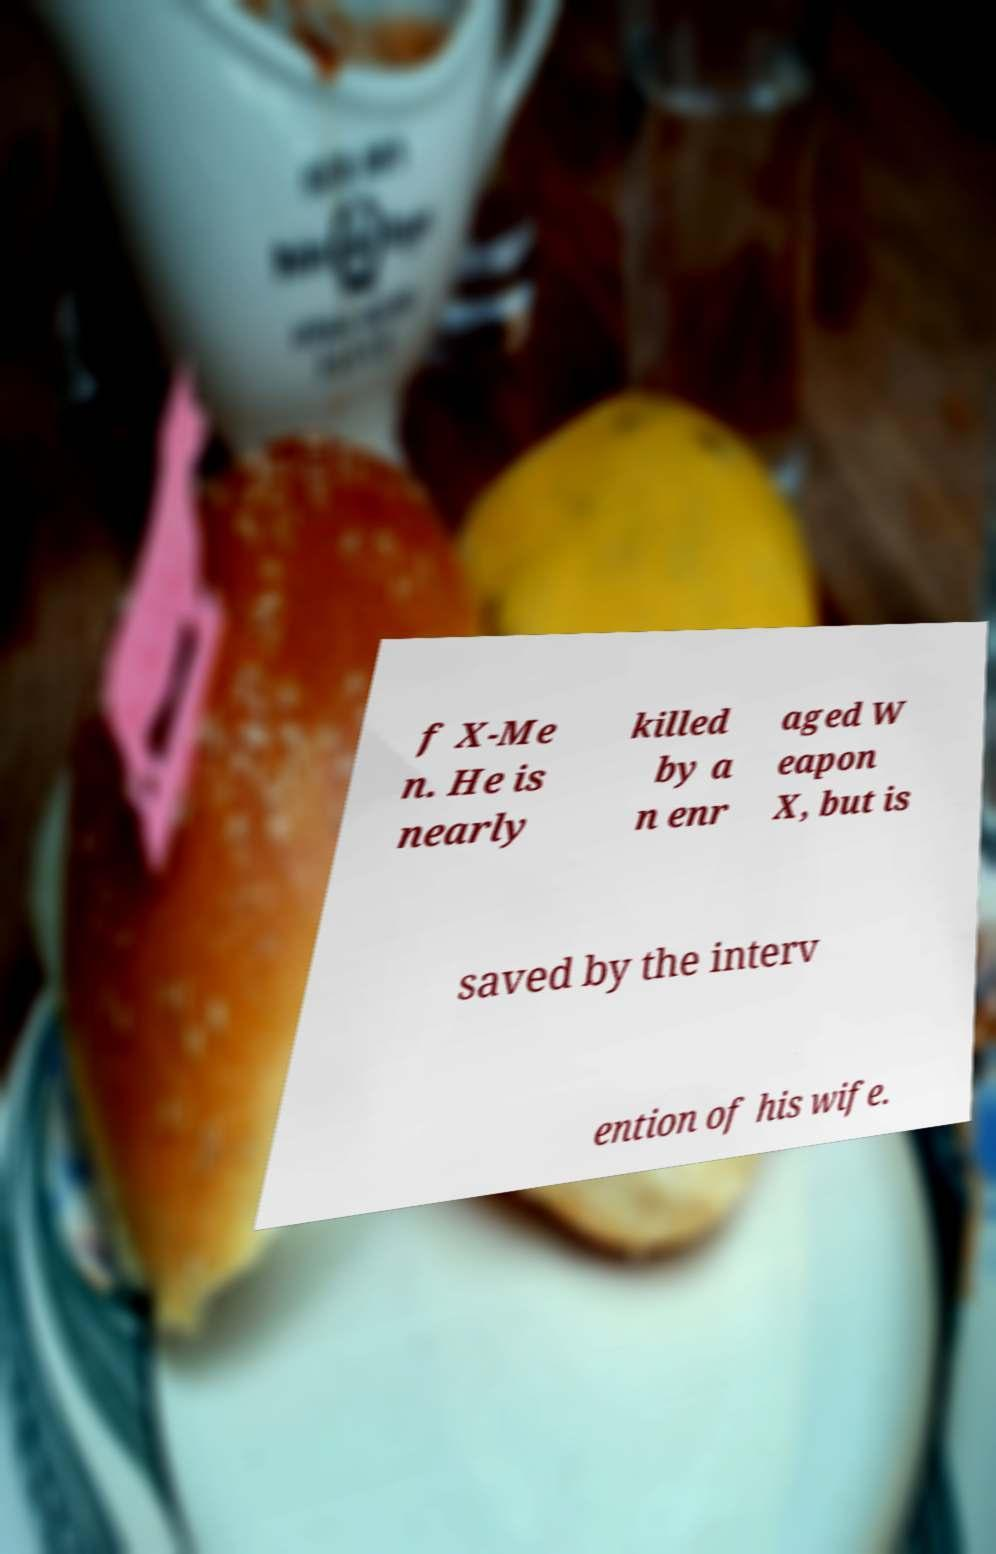I need the written content from this picture converted into text. Can you do that? f X-Me n. He is nearly killed by a n enr aged W eapon X, but is saved by the interv ention of his wife. 